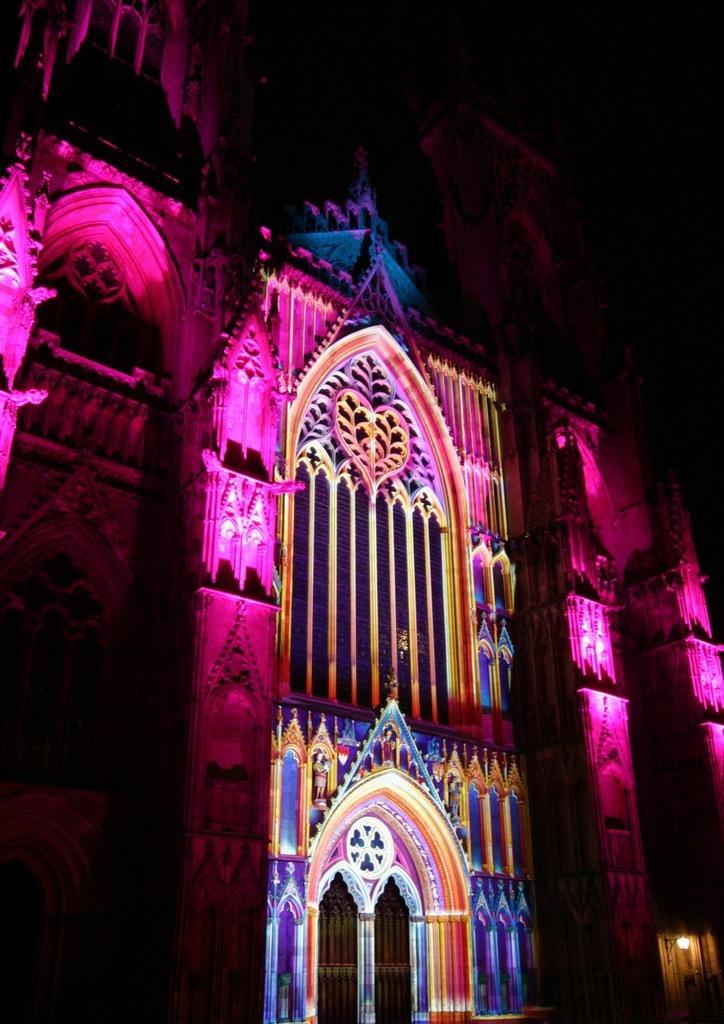Could you give a brief overview of what you see in this image? This is an image clicked in the dark. Here I can see a building. 